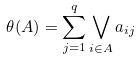<formula> <loc_0><loc_0><loc_500><loc_500>\theta ( A ) = \sum _ { j = 1 } ^ { q } \bigvee _ { i \in A } a _ { i j }</formula> 